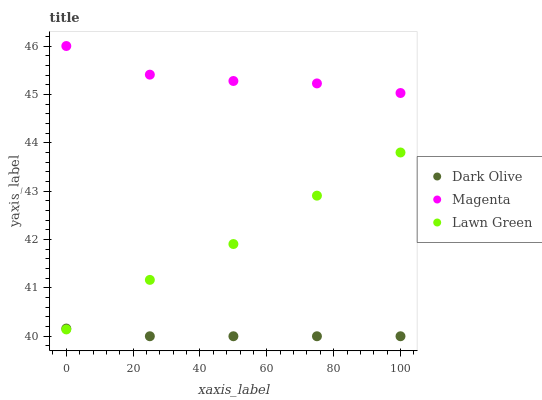Does Dark Olive have the minimum area under the curve?
Answer yes or no. Yes. Does Magenta have the maximum area under the curve?
Answer yes or no. Yes. Does Magenta have the minimum area under the curve?
Answer yes or no. No. Does Dark Olive have the maximum area under the curve?
Answer yes or no. No. Is Dark Olive the smoothest?
Answer yes or no. Yes. Is Magenta the roughest?
Answer yes or no. Yes. Is Magenta the smoothest?
Answer yes or no. No. Is Dark Olive the roughest?
Answer yes or no. No. Does Dark Olive have the lowest value?
Answer yes or no. Yes. Does Magenta have the lowest value?
Answer yes or no. No. Does Magenta have the highest value?
Answer yes or no. Yes. Does Dark Olive have the highest value?
Answer yes or no. No. Is Dark Olive less than Magenta?
Answer yes or no. Yes. Is Magenta greater than Dark Olive?
Answer yes or no. Yes. Does Lawn Green intersect Dark Olive?
Answer yes or no. Yes. Is Lawn Green less than Dark Olive?
Answer yes or no. No. Is Lawn Green greater than Dark Olive?
Answer yes or no. No. Does Dark Olive intersect Magenta?
Answer yes or no. No. 